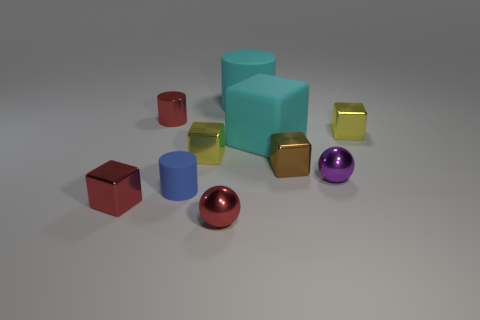How many matte objects are the same color as the rubber cube?
Your answer should be compact. 1. How many things are blue matte cylinders or cyan cylinders behind the purple metallic sphere?
Offer a terse response. 2. Does the tiny red cylinder on the left side of the small purple metallic object have the same material as the big cylinder?
Make the answer very short. No. The other metal ball that is the same size as the red ball is what color?
Provide a short and direct response. Purple. Is there a metallic object that has the same shape as the tiny blue matte object?
Ensure brevity in your answer.  Yes. There is a small metallic ball that is behind the tiny block that is in front of the rubber object in front of the tiny purple shiny sphere; what color is it?
Give a very brief answer. Purple. What number of metallic objects are tiny cubes or tiny blue spheres?
Provide a succinct answer. 4. Are there more yellow cubes on the left side of the small blue rubber object than yellow shiny blocks right of the cyan cube?
Offer a very short reply. No. What number of other objects are the same size as the cyan cylinder?
Provide a short and direct response. 1. There is a metallic cube on the left side of the yellow shiny block that is to the left of the red ball; what is its size?
Offer a very short reply. Small. 